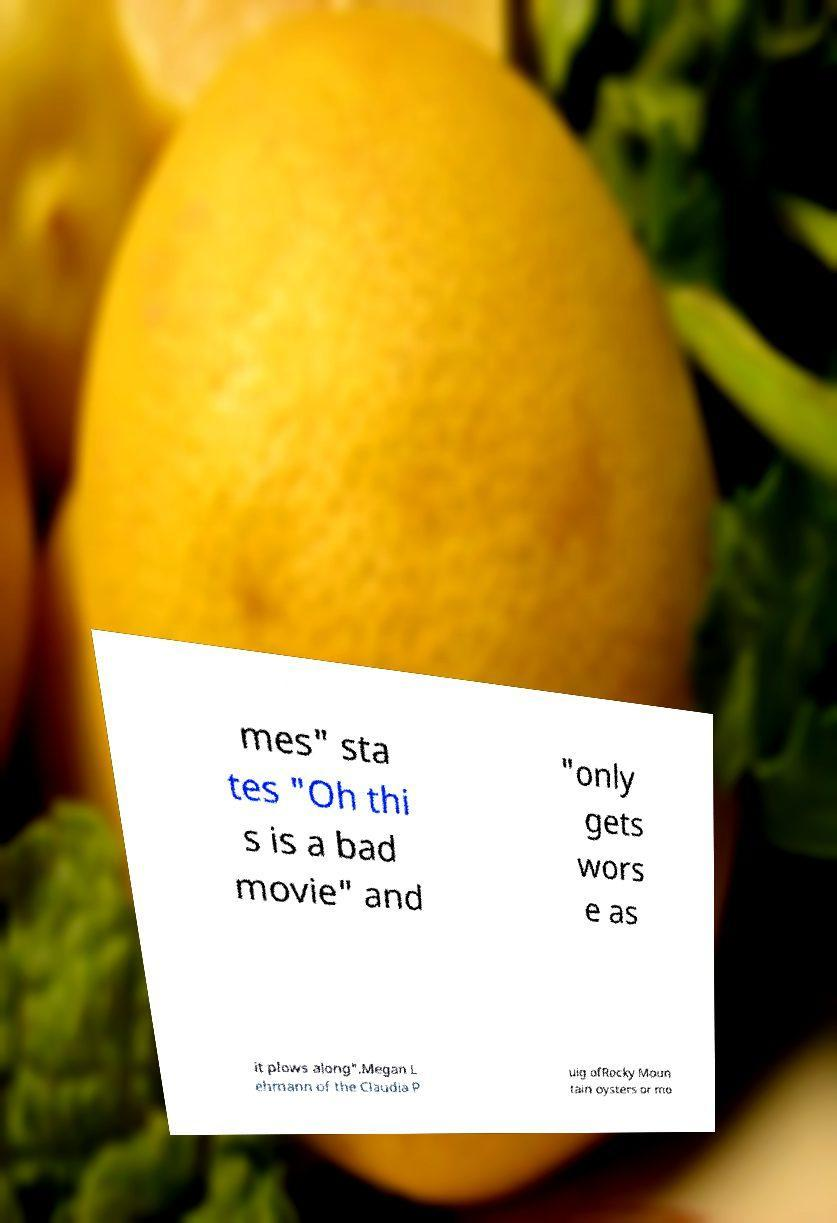There's text embedded in this image that I need extracted. Can you transcribe it verbatim? mes" sta tes "Oh thi s is a bad movie" and "only gets wors e as it plows along".Megan L ehmann of the Claudia P uig ofRocky Moun tain oysters or mo 